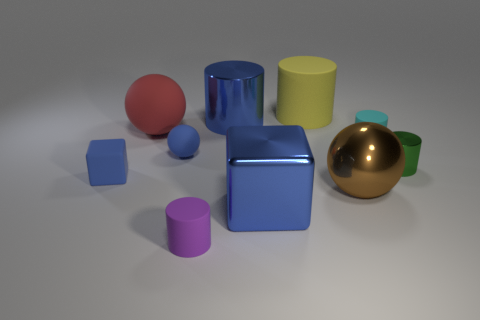What size is the matte sphere that is the same color as the big metal block?
Your answer should be very brief. Small. There is a matte thing that is the same color as the tiny ball; what shape is it?
Your response must be concise. Cube. What number of objects are either gray metallic balls or blue cylinders?
Your answer should be very brief. 1. What color is the matte cylinder that is to the left of the large cylinder behind the large blue object that is to the left of the large block?
Provide a short and direct response. Purple. Is there anything else that has the same color as the large matte sphere?
Your answer should be very brief. No. Is the size of the purple rubber object the same as the yellow matte thing?
Your answer should be compact. No. What number of things are objects left of the red matte object or big things to the left of the blue matte ball?
Your answer should be very brief. 2. There is a cylinder that is on the left side of the shiny thing that is behind the cyan rubber cylinder; what is it made of?
Your response must be concise. Rubber. How many other objects are the same material as the green object?
Keep it short and to the point. 3. Does the small shiny thing have the same shape as the brown thing?
Your answer should be compact. No. 